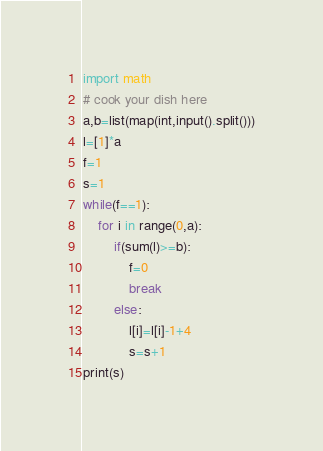<code> <loc_0><loc_0><loc_500><loc_500><_Python_>import math
# cook your dish here
a,b=list(map(int,input().split()))
l=[1]*a
f=1
s=1
while(f==1):
    for i in range(0,a):
        if(sum(l)>=b):
            f=0
            break
        else:
            l[i]=l[i]-1+4
            s=s+1
print(s)</code> 